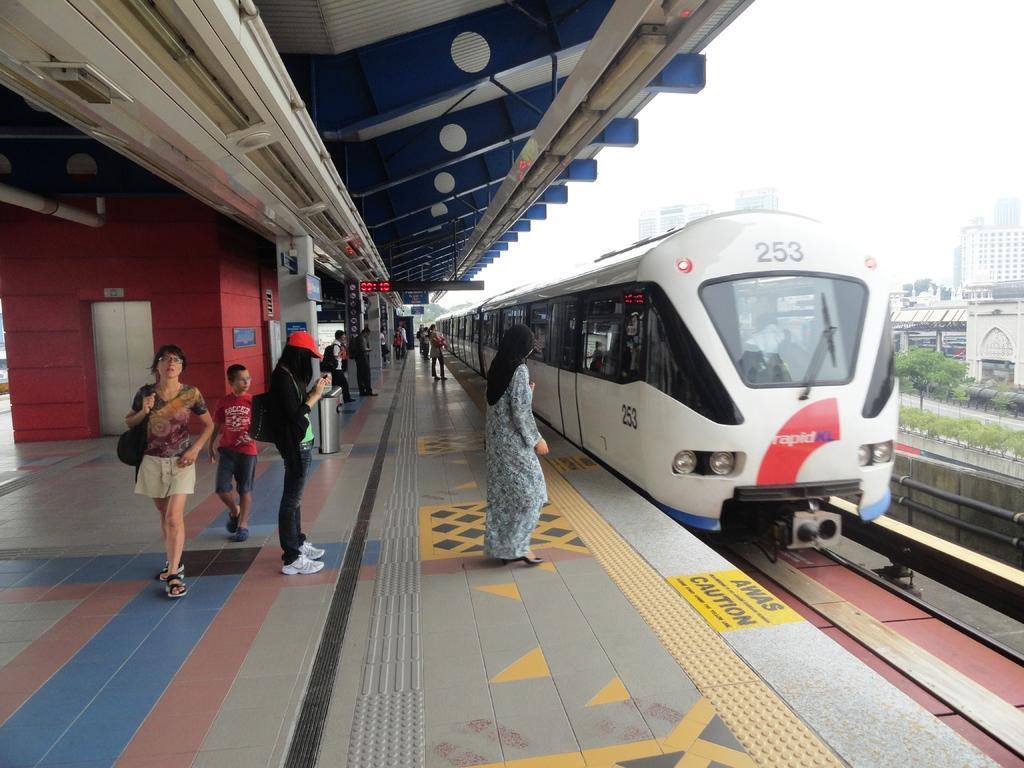Can you describe this image briefly? In this picture I can see the platform in front, on which there are of people standing and I can see a train on the right side of this picture and I see something is written on it. In the background I can see number of buildings, few trees and plants. In the middle of this picture I can see a lift and a screen and on the platform I can see few words written. 